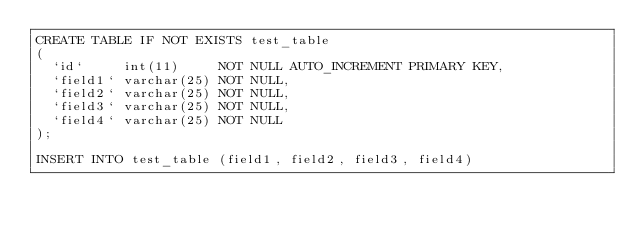<code> <loc_0><loc_0><loc_500><loc_500><_SQL_>CREATE TABLE IF NOT EXISTS test_table
(
  `id`     int(11)     NOT NULL AUTO_INCREMENT PRIMARY KEY,
  `field1` varchar(25) NOT NULL,
  `field2` varchar(25) NOT NULL,
  `field3` varchar(25) NOT NULL,
  `field4` varchar(25) NOT NULL
);

INSERT INTO test_table (field1, field2, field3, field4)</code> 